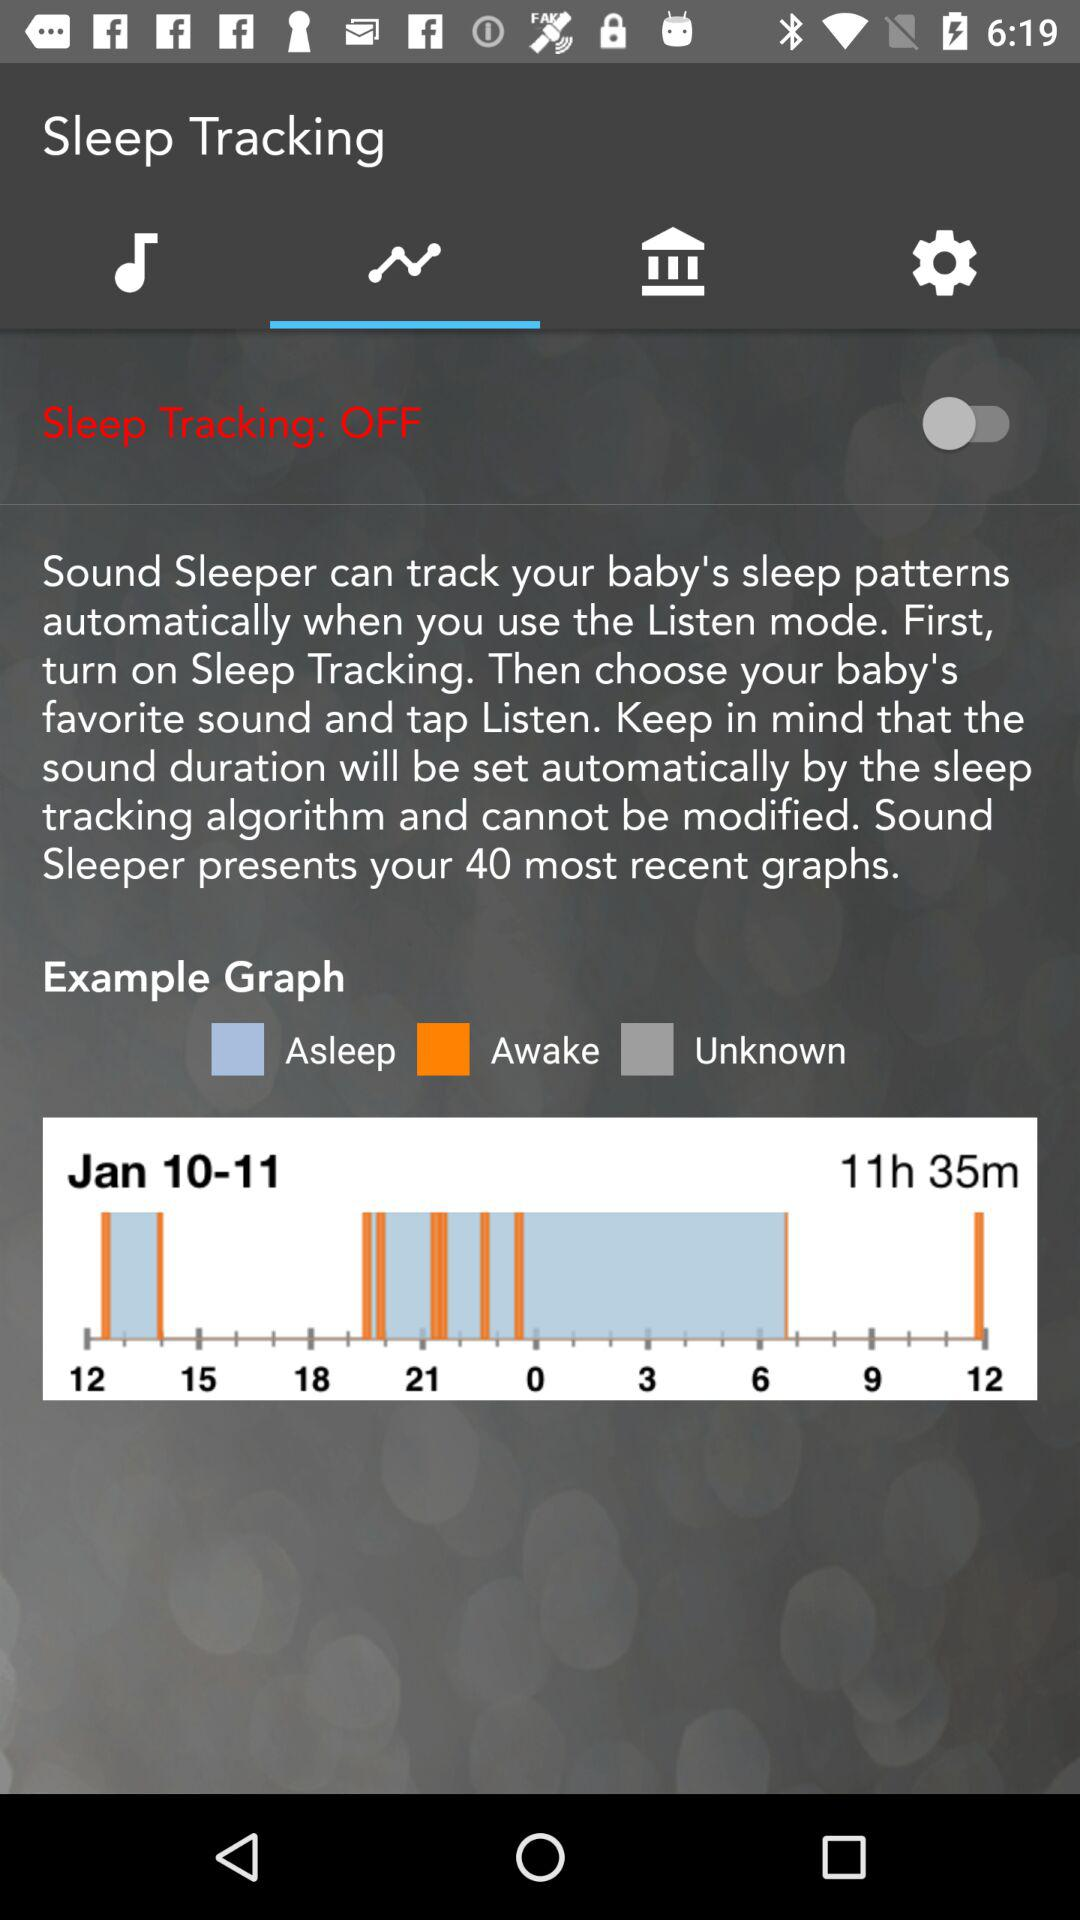What is the status of sleep tracking? The status of sleep tracking is "OFF". 